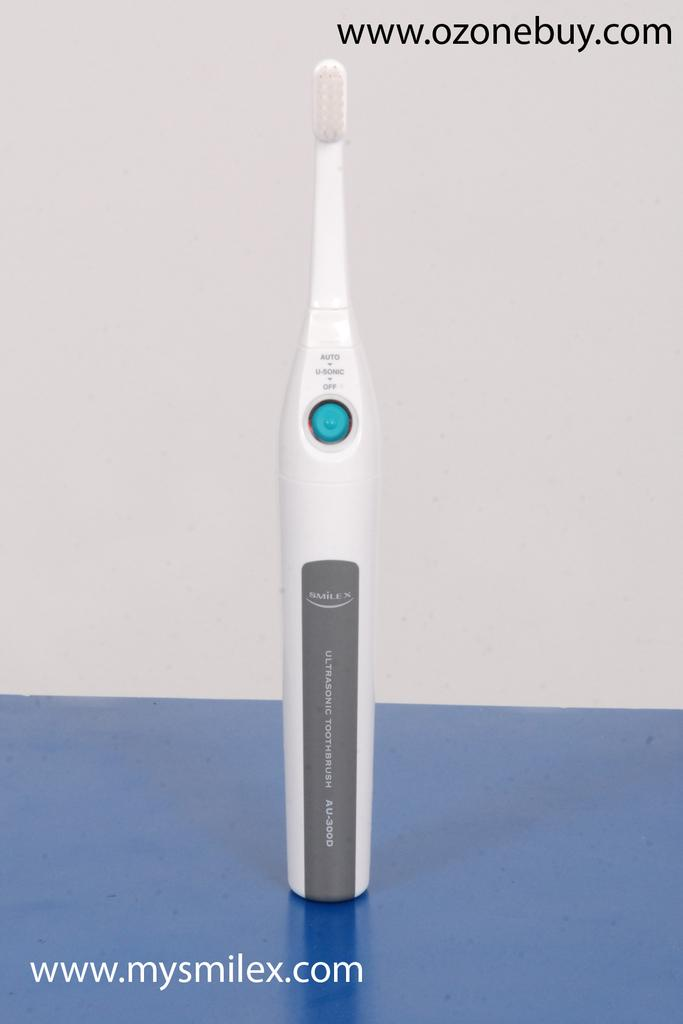What type of toothbrush is visible in the image? There is an electric toothbrush in the image. Where is the electric toothbrush located? The electric toothbrush is on a table. What can be seen in the background of the image? There is a wall in the background of the image. Can you tell me how many bells are ringing in the image? There are no bells present in the image. 